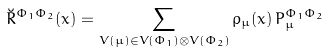Convert formula to latex. <formula><loc_0><loc_0><loc_500><loc_500>\breve { R } ^ { \Phi _ { 1 } \Phi _ { 2 } } ( x ) = \sum _ { V ( \mu ) \in V ( \Phi _ { 1 } ) \otimes V ( \Phi _ { 2 } ) } \rho _ { \mu } ( x ) \, { P } ^ { \Phi _ { 1 } \Phi _ { 2 } } _ { \mu }</formula> 